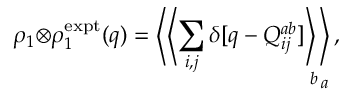<formula> <loc_0><loc_0><loc_500><loc_500>\rho _ { 1 } { \otimes } \rho _ { 1 } ^ { e x p t } ( q ) = \left \langle \left \langle \sum _ { i , j } \delta [ q - Q _ { i j } ^ { a b } ] \right \rangle _ { \, b } \right \rangle _ { \, a } ,</formula> 